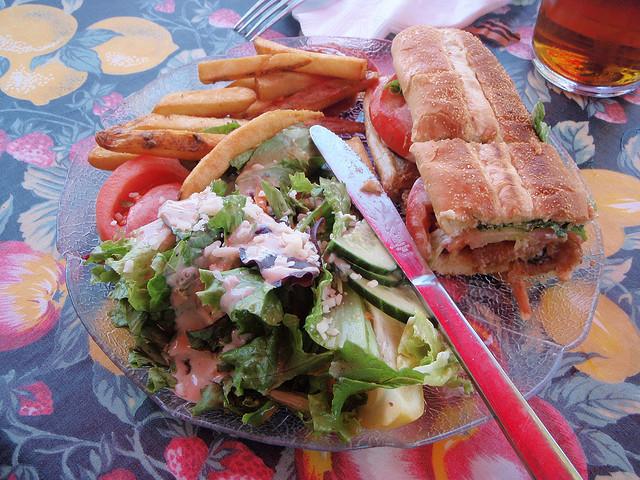Which utensil is on the plate?
Give a very brief answer. Knife. What is the butter knife leaning on?
Quick response, please. Salad. Is there a fork in the photo?
Keep it brief. Yes. 